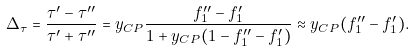Convert formula to latex. <formula><loc_0><loc_0><loc_500><loc_500>\Delta _ { \tau } = \frac { \tau ^ { \prime } - \tau ^ { \prime \prime } } { \tau ^ { \prime } + \tau ^ { \prime \prime } } = y _ { C P } \frac { f ^ { \prime \prime } _ { 1 } - f ^ { \prime } _ { 1 } } { 1 + y _ { C P } ( 1 - f ^ { \prime \prime } _ { 1 } - f ^ { \prime } _ { 1 } ) } \approx y _ { C P } ( f ^ { \prime \prime } _ { 1 } - f ^ { \prime } _ { 1 } ) .</formula> 